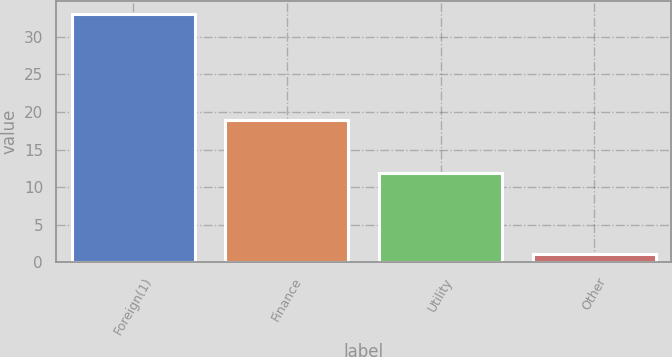Convert chart to OTSL. <chart><loc_0><loc_0><loc_500><loc_500><bar_chart><fcel>Foreign(1)<fcel>Finance<fcel>Utility<fcel>Other<nl><fcel>33.1<fcel>19<fcel>11.9<fcel>1.1<nl></chart> 